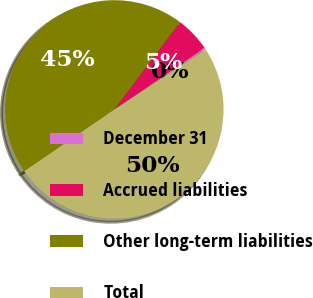Convert chart to OTSL. <chart><loc_0><loc_0><loc_500><loc_500><pie_chart><fcel>December 31<fcel>Accrued liabilities<fcel>Other long-term liabilities<fcel>Total<nl><fcel>0.27%<fcel>5.17%<fcel>44.83%<fcel>49.73%<nl></chart> 